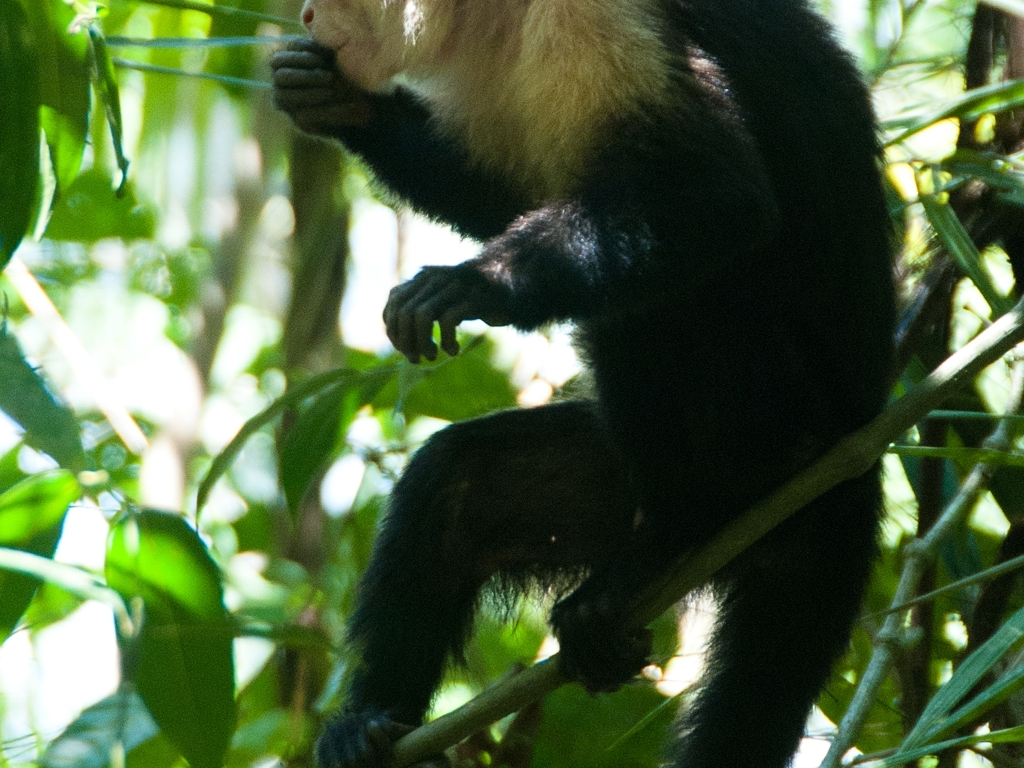Considering the environment, what can we infer about the animal's habitat and natural behaviors? The dense foliage and dappled sunlight in the background are indicative of a dense forest or jungle habitat, likely a tropical or subtropical region. The primate's grasping hand and foot indicate adaptations for life in the trees, suggesting an arboreal lifestyle where it climbs, leaps, and forages among the treetops. 